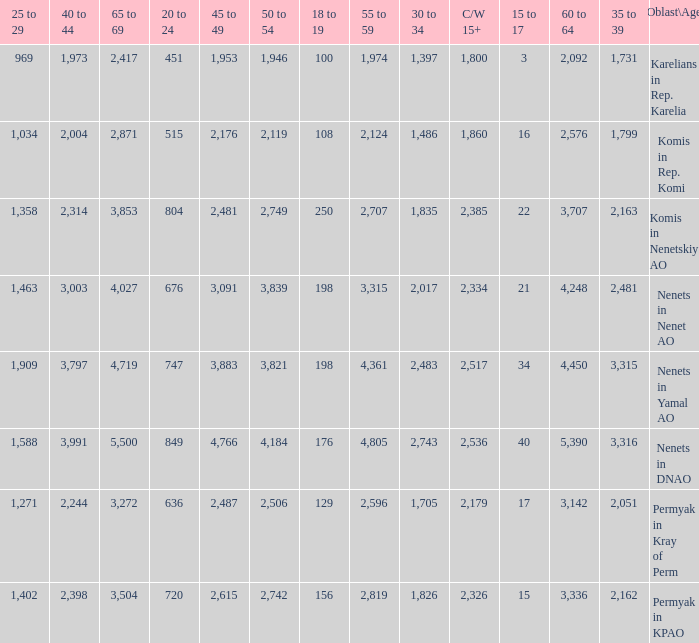What is the number of 40 to 44 when the 50 to 54 is less than 4,184, and the 15 to 17 is less than 3? 0.0. 